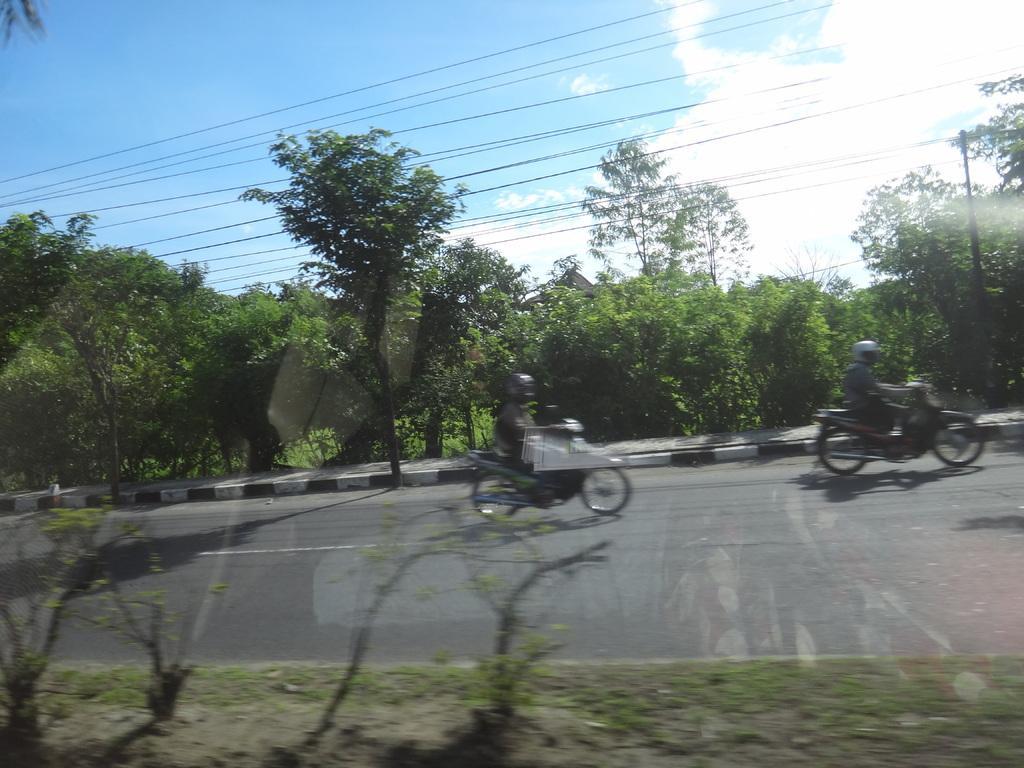Could you give a brief overview of what you see in this image? There is a road. On the road there are motorcycles. Persons wearing helmet is sitting on that and riding. On the sides of the road there are grasses and trees. Also there is a electric pole with wires. In the background there is sky with clouds. 